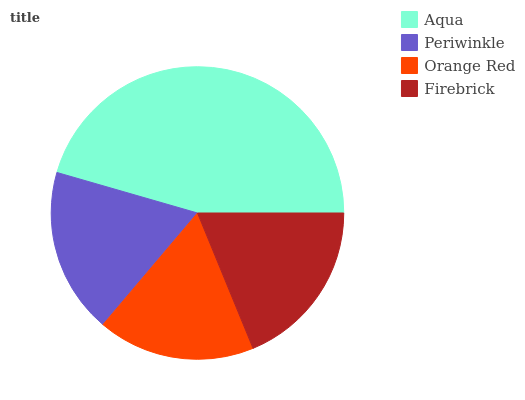Is Orange Red the minimum?
Answer yes or no. Yes. Is Aqua the maximum?
Answer yes or no. Yes. Is Periwinkle the minimum?
Answer yes or no. No. Is Periwinkle the maximum?
Answer yes or no. No. Is Aqua greater than Periwinkle?
Answer yes or no. Yes. Is Periwinkle less than Aqua?
Answer yes or no. Yes. Is Periwinkle greater than Aqua?
Answer yes or no. No. Is Aqua less than Periwinkle?
Answer yes or no. No. Is Firebrick the high median?
Answer yes or no. Yes. Is Periwinkle the low median?
Answer yes or no. Yes. Is Orange Red the high median?
Answer yes or no. No. Is Orange Red the low median?
Answer yes or no. No. 